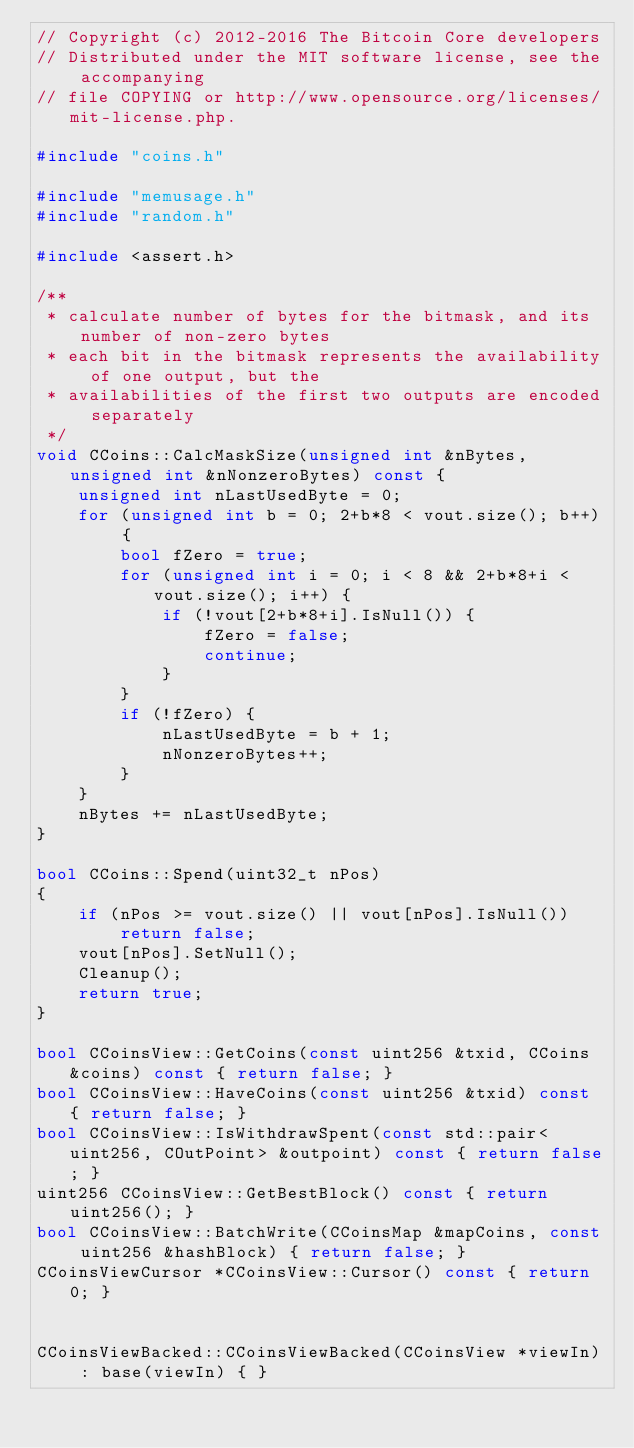<code> <loc_0><loc_0><loc_500><loc_500><_C++_>// Copyright (c) 2012-2016 The Bitcoin Core developers
// Distributed under the MIT software license, see the accompanying
// file COPYING or http://www.opensource.org/licenses/mit-license.php.

#include "coins.h"

#include "memusage.h"
#include "random.h"

#include <assert.h>

/**
 * calculate number of bytes for the bitmask, and its number of non-zero bytes
 * each bit in the bitmask represents the availability of one output, but the
 * availabilities of the first two outputs are encoded separately
 */
void CCoins::CalcMaskSize(unsigned int &nBytes, unsigned int &nNonzeroBytes) const {
    unsigned int nLastUsedByte = 0;
    for (unsigned int b = 0; 2+b*8 < vout.size(); b++) {
        bool fZero = true;
        for (unsigned int i = 0; i < 8 && 2+b*8+i < vout.size(); i++) {
            if (!vout[2+b*8+i].IsNull()) {
                fZero = false;
                continue;
            }
        }
        if (!fZero) {
            nLastUsedByte = b + 1;
            nNonzeroBytes++;
        }
    }
    nBytes += nLastUsedByte;
}

bool CCoins::Spend(uint32_t nPos) 
{
    if (nPos >= vout.size() || vout[nPos].IsNull())
        return false;
    vout[nPos].SetNull();
    Cleanup();
    return true;
}

bool CCoinsView::GetCoins(const uint256 &txid, CCoins &coins) const { return false; }
bool CCoinsView::HaveCoins(const uint256 &txid) const { return false; }
bool CCoinsView::IsWithdrawSpent(const std::pair<uint256, COutPoint> &outpoint) const { return false; }
uint256 CCoinsView::GetBestBlock() const { return uint256(); }
bool CCoinsView::BatchWrite(CCoinsMap &mapCoins, const uint256 &hashBlock) { return false; }
CCoinsViewCursor *CCoinsView::Cursor() const { return 0; }


CCoinsViewBacked::CCoinsViewBacked(CCoinsView *viewIn) : base(viewIn) { }</code> 